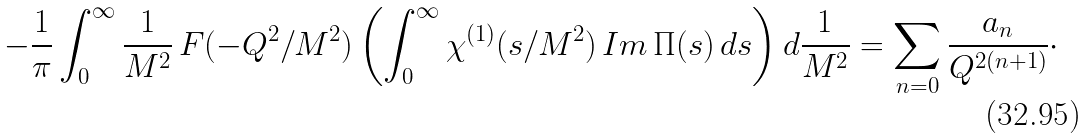Convert formula to latex. <formula><loc_0><loc_0><loc_500><loc_500>- \frac { 1 } { \pi } \int _ { 0 } ^ { \infty } \frac { 1 } { M ^ { 2 } } \, F ( - Q ^ { 2 } / M ^ { 2 } ) \left ( \int _ { 0 } ^ { \infty } \chi ^ { ( 1 ) } ( s / M ^ { 2 } ) \, I m \, \Pi ( s ) \, d s \right ) d \frac { 1 } { M ^ { 2 } } = \sum _ { n = 0 } \frac { a _ { n } } { Q ^ { 2 ( n + 1 ) } } \cdot</formula> 